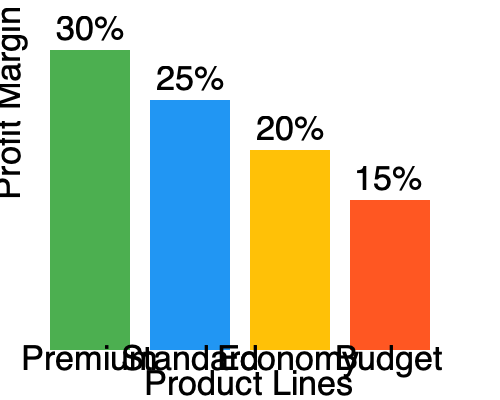A large corporation offers four product lines with varying price points and profit margins. Based on the bar graph showing profit margins for different product lines, calculate the difference in profit margin percentage between the highest and lowest margin products. How might this information influence the corporation's pricing and marketing strategies? To solve this problem, we need to follow these steps:

1. Identify the highest and lowest profit margins from the graph:
   - Premium: 30%
   - Standard: 25%
   - Economy: 20%
   - Budget: 15%

2. Calculate the difference between the highest and lowest profit margins:
   $30\% - 15\% = 15\%$

3. Consider the implications for pricing and marketing strategies:
   a) Price skimming: The corporation could focus on promoting the Premium line to capture high-margin sales from customers willing to pay more for quality.
   
   b) Product mix optimization: They could adjust the production and marketing focus to emphasize higher-margin products.
   
   c) Upselling and cross-selling: Develop strategies to encourage customers to move from Budget to higher-margin product lines.
   
   d) Cost management: Investigate ways to reduce costs in the Budget line to improve its profit margin without increasing prices.
   
   e) Value proposition: Clearly communicate the benefits of higher-priced products to justify the price difference and maintain the higher margins.
   
   f) Market segmentation: Target different customer segments with each product line, tailoring marketing messages to highlight value at each price point.
Answer: 15%; strategies include price skimming, product mix optimization, upselling, cost management, value proposition emphasis, and market segmentation. 